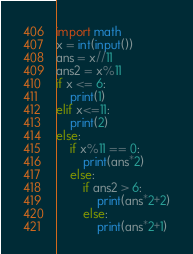Convert code to text. <code><loc_0><loc_0><loc_500><loc_500><_Python_>import math
x = int(input())
ans = x//11
ans2 = x%11
if x <= 6:
    print(1)
elif x<=11:
    print(2)
else:
    if x%11 == 0:
        print(ans*2)
    else:
        if ans2 > 6:
            print(ans*2+2)
        else:
            print(ans*2+1)
</code> 